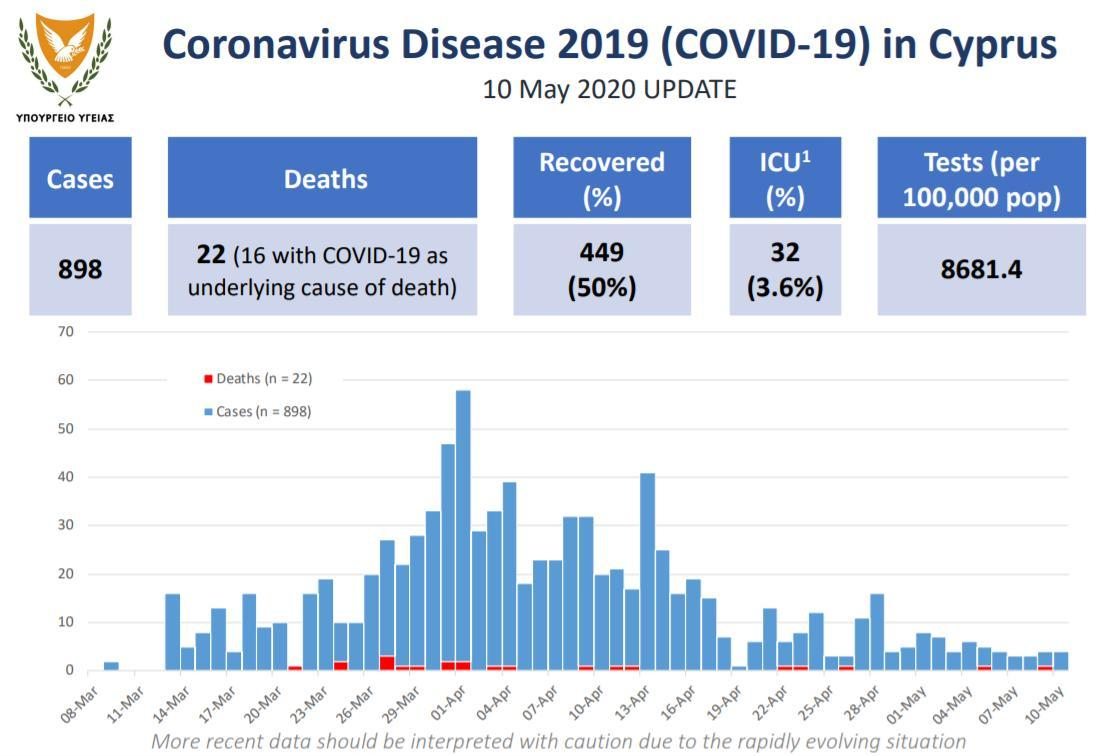On which of may the first death case were reported?
Answer the question with a short phrase. 5 may 2020 On which day of march were there only deaths were reported and not any confirmed cases ? 21 march 2020 On which day the lowest number of cases were reported in april? 19 april 2020 On which day the third highest cases were reported? 13 april 2020 what was the number of cases reported in 25 march 2020? 10 ON WHICH DAY THE HIGHEST NUMBER OF DEATHS ARE REPORTED? 27 MARCH 2020 